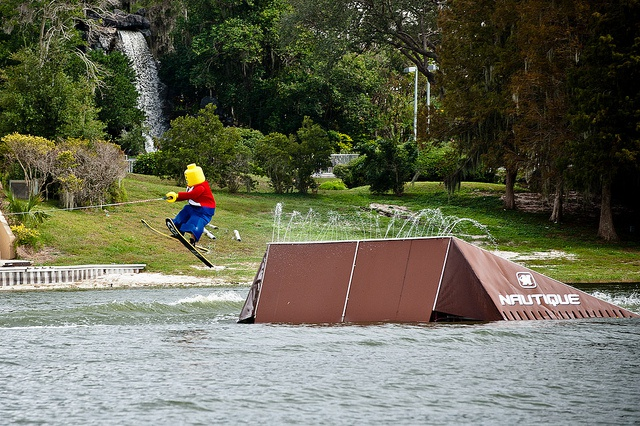Describe the objects in this image and their specific colors. I can see people in gray, navy, darkblue, red, and maroon tones and skis in gray, black, khaki, and tan tones in this image. 